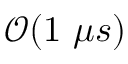<formula> <loc_0><loc_0><loc_500><loc_500>\mathcal { O } ( 1 \mu s )</formula> 